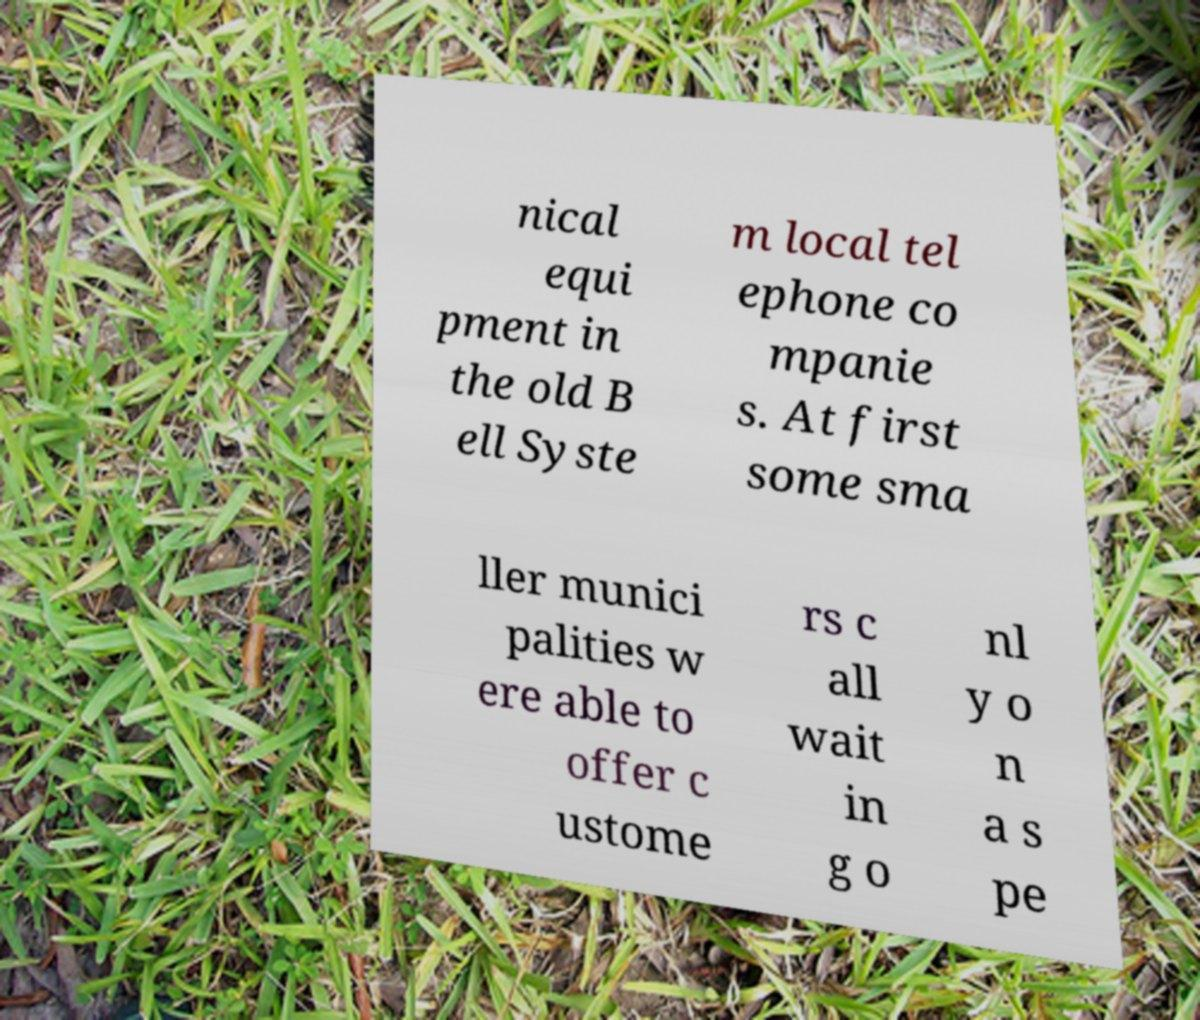I need the written content from this picture converted into text. Can you do that? nical equi pment in the old B ell Syste m local tel ephone co mpanie s. At first some sma ller munici palities w ere able to offer c ustome rs c all wait in g o nl y o n a s pe 